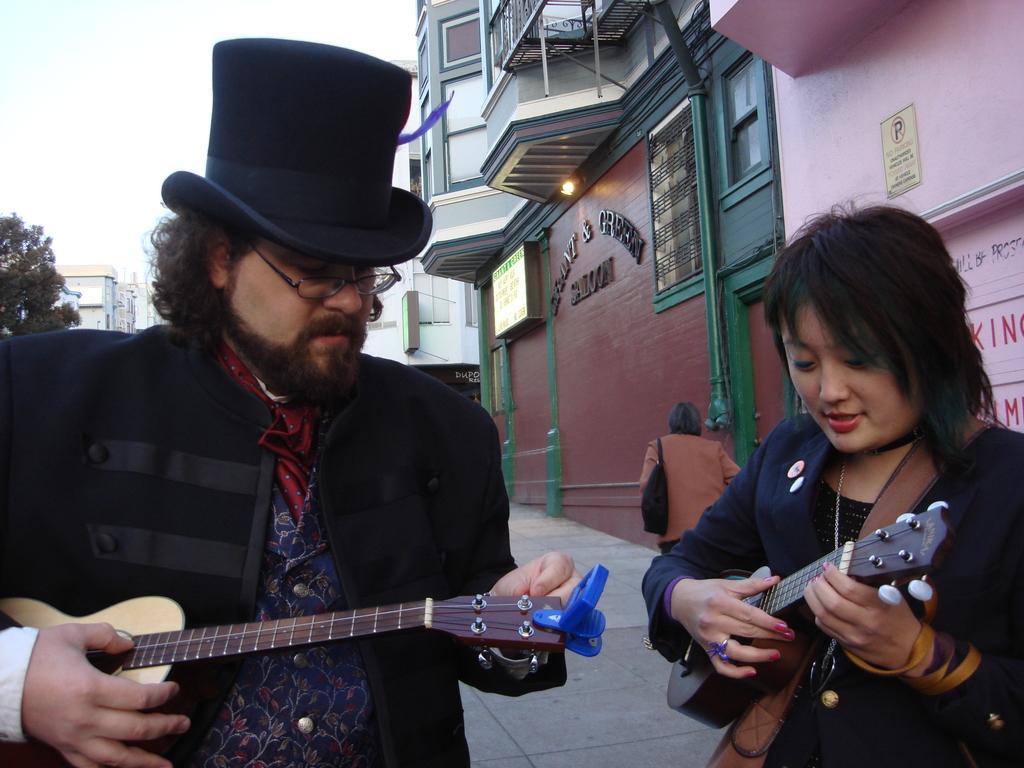Can you describe this image briefly? In the picture we can see a man and woman standing and holding a guitar, a man is wearing a hat, In the background we can find a person walking just beside to that person we can find a buildings and sky. 